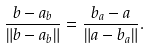<formula> <loc_0><loc_0><loc_500><loc_500>\frac { b - a _ { b } } { \| b - a _ { b } \| } = \frac { b _ { a } - a } { \| a - b _ { a } \| } .</formula> 